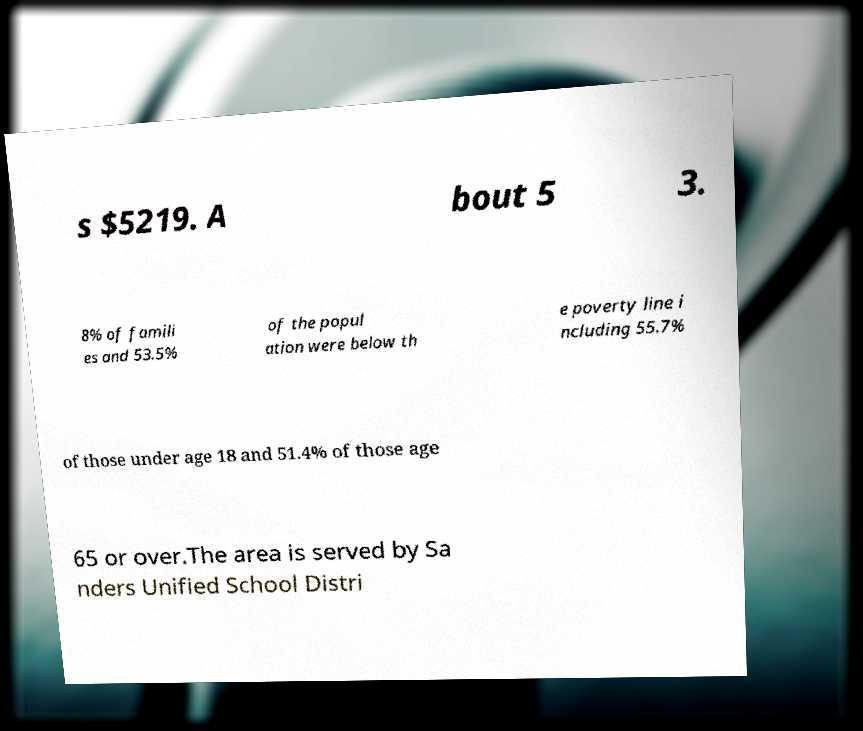Could you extract and type out the text from this image? s $5219. A bout 5 3. 8% of famili es and 53.5% of the popul ation were below th e poverty line i ncluding 55.7% of those under age 18 and 51.4% of those age 65 or over.The area is served by Sa nders Unified School Distri 